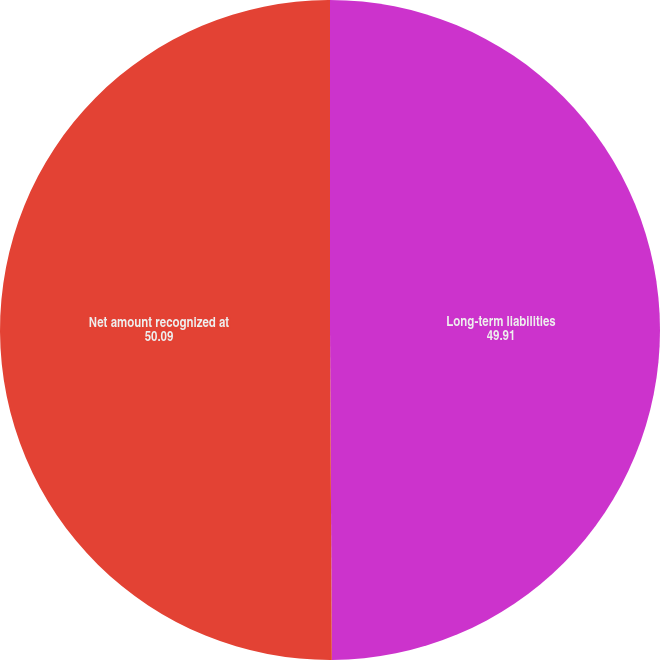Convert chart to OTSL. <chart><loc_0><loc_0><loc_500><loc_500><pie_chart><fcel>Long-term liabilities<fcel>Net amount recognized at<nl><fcel>49.91%<fcel>50.09%<nl></chart> 